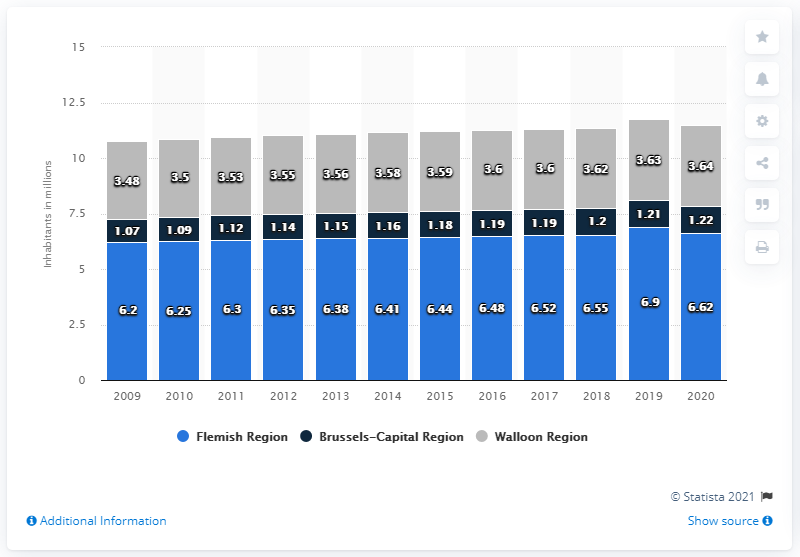Give some essential details in this illustration. According to the given information, it is estimated that 3.63 people lived in the Walloon Region. As of 2021, it is estimated that approximately 1.21 million people resided in the Brussels and surrounding areas. 